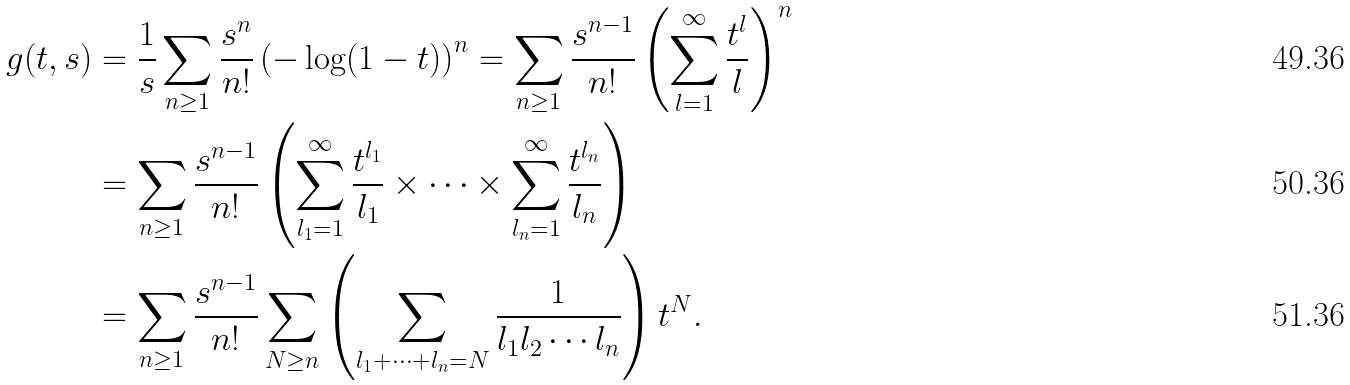<formula> <loc_0><loc_0><loc_500><loc_500>g ( t , s ) & = \frac { 1 } { s } \sum _ { n \geq 1 } \frac { s ^ { n } } { n ! } \left ( - \log ( 1 - t ) \right ) ^ { n } = \sum _ { n \geq 1 } \frac { s ^ { n - 1 } } { n ! } \left ( \sum _ { l = 1 } ^ { \infty } \frac { t ^ { l } } { l } \right ) ^ { n } \\ & = \sum _ { n \geq 1 } \frac { s ^ { n - 1 } } { n ! } \left ( \sum _ { l _ { 1 } = 1 } ^ { \infty } \frac { t ^ { l _ { 1 } } } { l _ { 1 } } \times \cdots \times \sum _ { l _ { n } = 1 } ^ { \infty } \frac { t ^ { l _ { n } } } { l _ { n } } \right ) \\ & = \sum _ { n \geq 1 } \frac { s ^ { n - 1 } } { n ! } \sum _ { N \geq n } \left ( \sum _ { l _ { 1 } + \cdots + l _ { n } = N } \frac { 1 } { l _ { 1 } l _ { 2 } \cdots l _ { n } } \right ) t ^ { N } .</formula> 